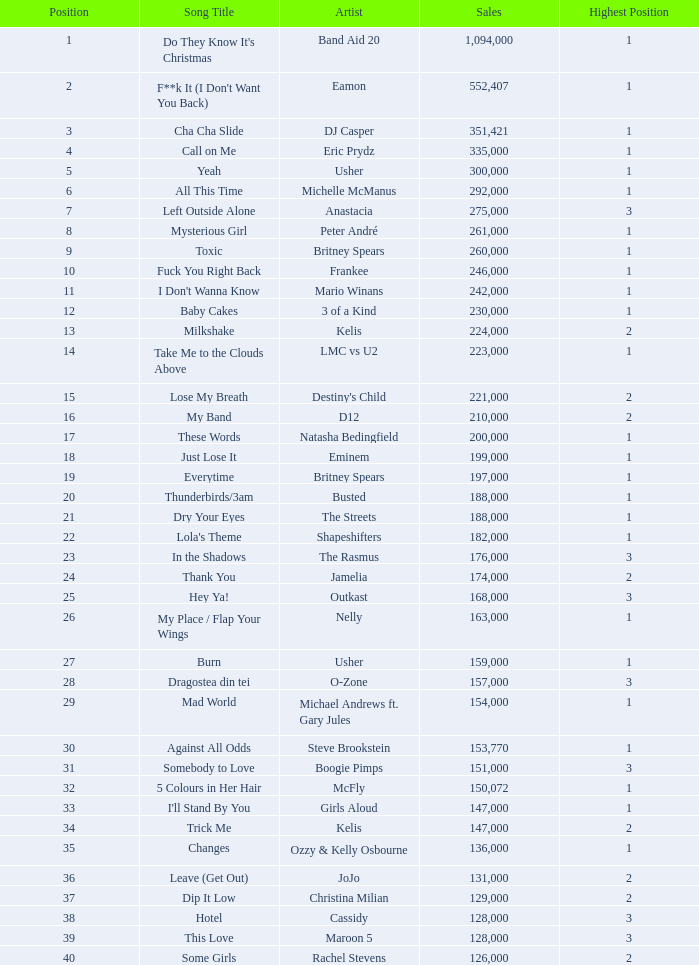When dj casper's rank was lower than 13, what were his sales figures? 351421.0. 